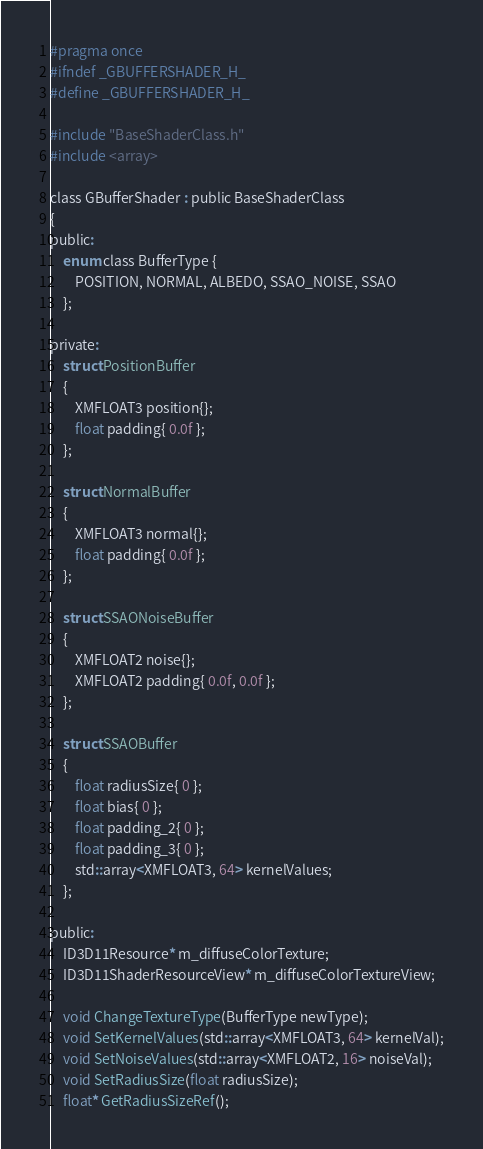<code> <loc_0><loc_0><loc_500><loc_500><_C_>#pragma once
#ifndef _GBUFFERSHADER_H_
#define _GBUFFERSHADER_H_

#include "BaseShaderClass.h"
#include <array>

class GBufferShader : public BaseShaderClass 
{
public:
	enum class BufferType {
		POSITION, NORMAL, ALBEDO, SSAO_NOISE, SSAO
	};

private:
	struct PositionBuffer
	{
		XMFLOAT3 position{};
		float padding{ 0.0f };
	};

	struct NormalBuffer
	{
		XMFLOAT3 normal{};
		float padding{ 0.0f };
	};

	struct SSAONoiseBuffer
	{
		XMFLOAT2 noise{};
		XMFLOAT2 padding{ 0.0f, 0.0f };
	};

	struct SSAOBuffer
	{
		float radiusSize{ 0 };
		float bias{ 0 };
		float padding_2{ 0 };
		float padding_3{ 0 };
		std::array<XMFLOAT3, 64> kernelValues;
	};

public:
	ID3D11Resource* m_diffuseColorTexture;
	ID3D11ShaderResourceView* m_diffuseColorTextureView;

	void ChangeTextureType(BufferType newType);
	void SetKernelValues(std::array<XMFLOAT3, 64> kernelVal);
	void SetNoiseValues(std::array<XMFLOAT2, 16> noiseVal);
	void SetRadiusSize(float radiusSize);
	float* GetRadiusSizeRef();
</code> 